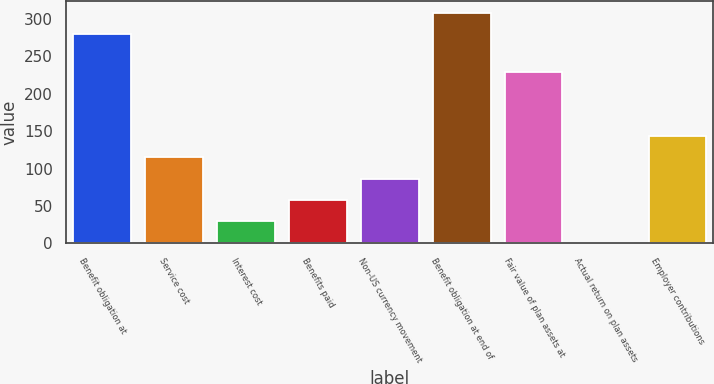Convert chart. <chart><loc_0><loc_0><loc_500><loc_500><bar_chart><fcel>Benefit obligation at<fcel>Service cost<fcel>Interest cost<fcel>Benefits paid<fcel>Non-US currency movement<fcel>Benefit obligation at end of<fcel>Fair value of plan assets at<fcel>Actual return on plan assets<fcel>Employer contributions<nl><fcel>279<fcel>115<fcel>29.5<fcel>58<fcel>86.5<fcel>307.5<fcel>229<fcel>1<fcel>143.5<nl></chart> 